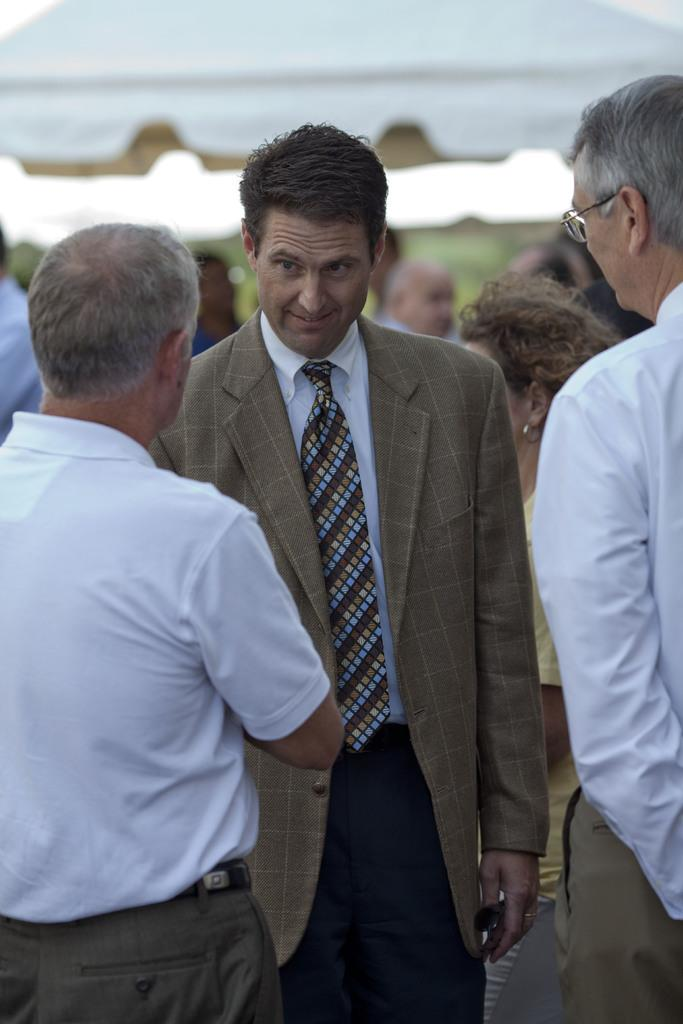What is happening in the image? There are people standing in the image. Can you describe the appearance of one of the men? One man is wearing spectacles. How is another man dressed? Another man is wearing a coat and a tie. What color are the shirts of some of the men? Some men are wearing white color shirts. What is the topic of the meeting that is taking place in the image? There is no indication of a meeting in the image; it simply shows people standing. How many times does the man in the coat sneeze in the image? There is no indication of anyone sneezing in the image. 